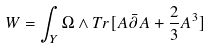<formula> <loc_0><loc_0><loc_500><loc_500>W = \int _ { Y } \Omega \wedge T r [ A \bar { \partial } A + \frac { 2 } { 3 } A ^ { 3 } ]</formula> 